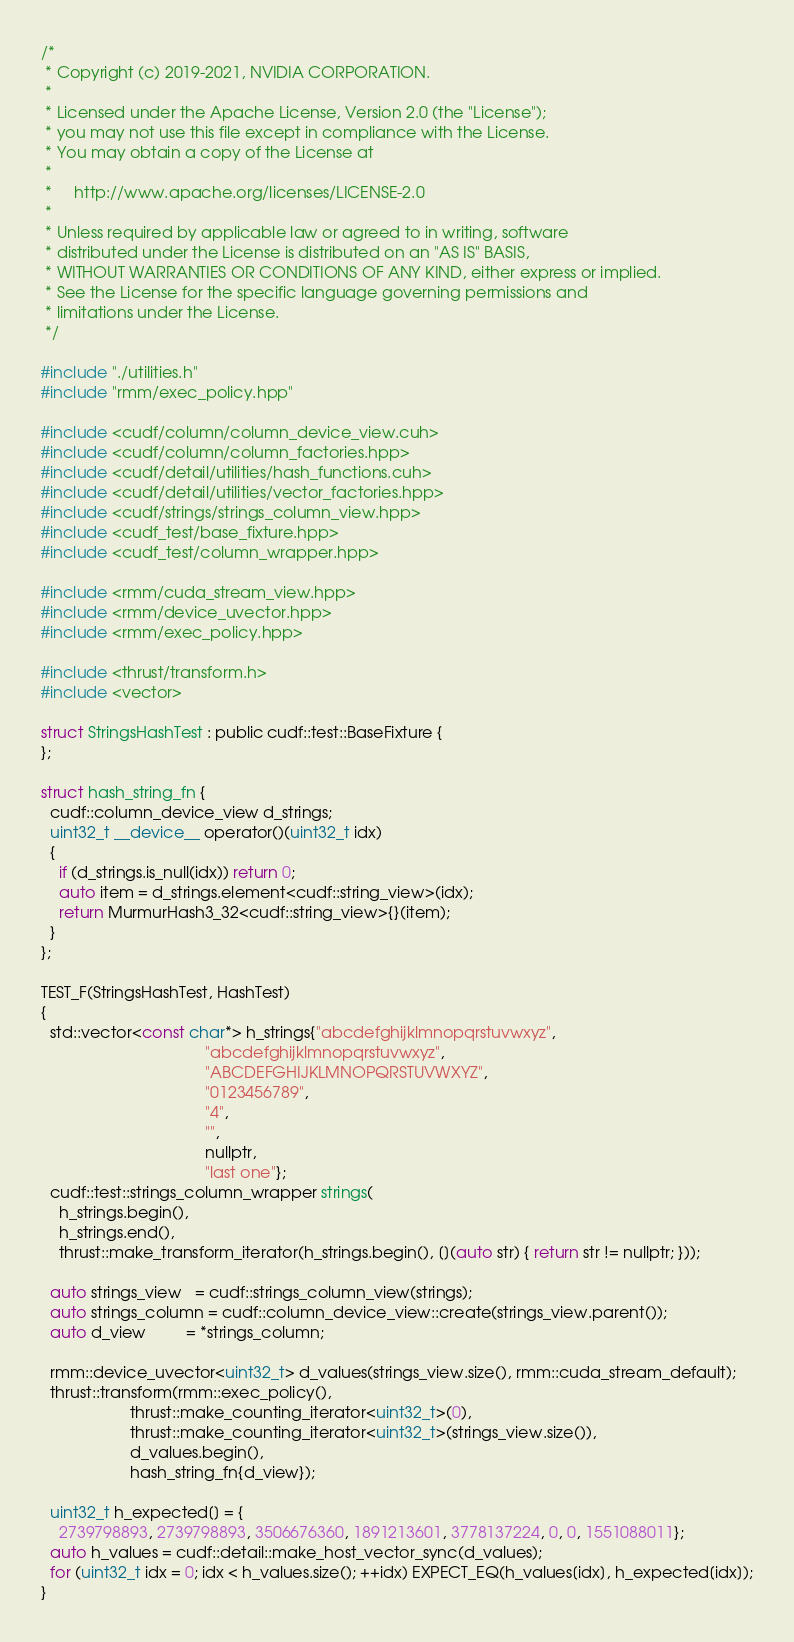<code> <loc_0><loc_0><loc_500><loc_500><_Cuda_>/*
 * Copyright (c) 2019-2021, NVIDIA CORPORATION.
 *
 * Licensed under the Apache License, Version 2.0 (the "License");
 * you may not use this file except in compliance with the License.
 * You may obtain a copy of the License at
 *
 *     http://www.apache.org/licenses/LICENSE-2.0
 *
 * Unless required by applicable law or agreed to in writing, software
 * distributed under the License is distributed on an "AS IS" BASIS,
 * WITHOUT WARRANTIES OR CONDITIONS OF ANY KIND, either express or implied.
 * See the License for the specific language governing permissions and
 * limitations under the License.
 */

#include "./utilities.h"
#include "rmm/exec_policy.hpp"

#include <cudf/column/column_device_view.cuh>
#include <cudf/column/column_factories.hpp>
#include <cudf/detail/utilities/hash_functions.cuh>
#include <cudf/detail/utilities/vector_factories.hpp>
#include <cudf/strings/strings_column_view.hpp>
#include <cudf_test/base_fixture.hpp>
#include <cudf_test/column_wrapper.hpp>

#include <rmm/cuda_stream_view.hpp>
#include <rmm/device_uvector.hpp>
#include <rmm/exec_policy.hpp>

#include <thrust/transform.h>
#include <vector>

struct StringsHashTest : public cudf::test::BaseFixture {
};

struct hash_string_fn {
  cudf::column_device_view d_strings;
  uint32_t __device__ operator()(uint32_t idx)
  {
    if (d_strings.is_null(idx)) return 0;
    auto item = d_strings.element<cudf::string_view>(idx);
    return MurmurHash3_32<cudf::string_view>{}(item);
  }
};

TEST_F(StringsHashTest, HashTest)
{
  std::vector<const char*> h_strings{"abcdefghijklmnopqrstuvwxyz",
                                     "abcdefghijklmnopqrstuvwxyz",
                                     "ABCDEFGHIJKLMNOPQRSTUVWXYZ",
                                     "0123456789",
                                     "4",
                                     "",
                                     nullptr,
                                     "last one"};
  cudf::test::strings_column_wrapper strings(
    h_strings.begin(),
    h_strings.end(),
    thrust::make_transform_iterator(h_strings.begin(), [](auto str) { return str != nullptr; }));

  auto strings_view   = cudf::strings_column_view(strings);
  auto strings_column = cudf::column_device_view::create(strings_view.parent());
  auto d_view         = *strings_column;

  rmm::device_uvector<uint32_t> d_values(strings_view.size(), rmm::cuda_stream_default);
  thrust::transform(rmm::exec_policy(),
                    thrust::make_counting_iterator<uint32_t>(0),
                    thrust::make_counting_iterator<uint32_t>(strings_view.size()),
                    d_values.begin(),
                    hash_string_fn{d_view});

  uint32_t h_expected[] = {
    2739798893, 2739798893, 3506676360, 1891213601, 3778137224, 0, 0, 1551088011};
  auto h_values = cudf::detail::make_host_vector_sync(d_values);
  for (uint32_t idx = 0; idx < h_values.size(); ++idx) EXPECT_EQ(h_values[idx], h_expected[idx]);
}
</code> 